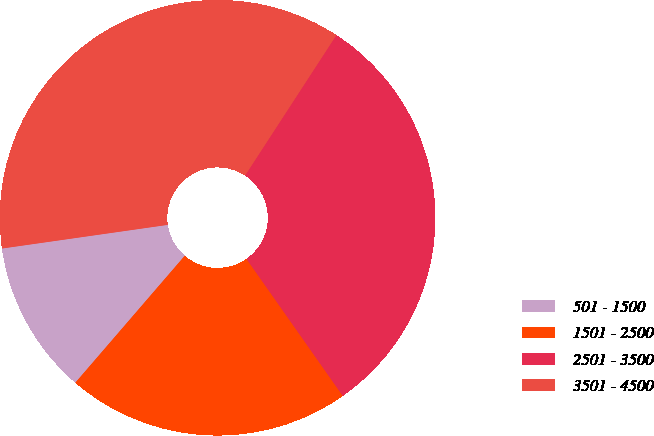<chart> <loc_0><loc_0><loc_500><loc_500><pie_chart><fcel>501 - 1500<fcel>1501 - 2500<fcel>2501 - 3500<fcel>3501 - 4500<nl><fcel>11.42%<fcel>21.07%<fcel>31.07%<fcel>36.43%<nl></chart> 